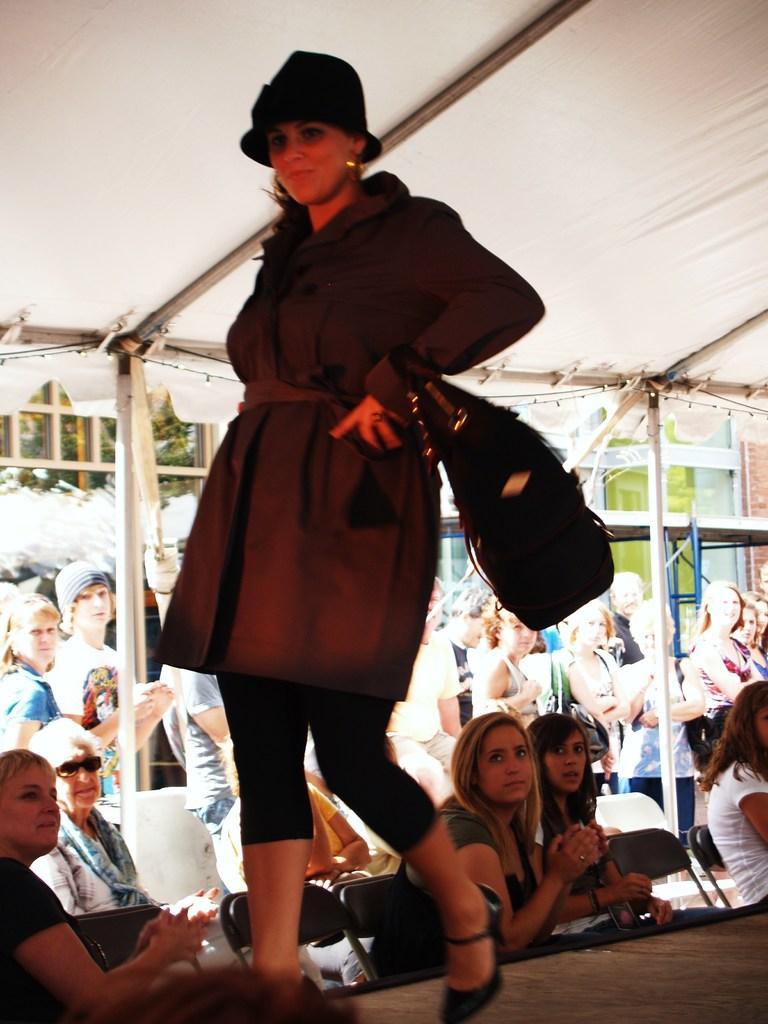Could you give a brief overview of what you see in this image? In the center of the image we can see a lady is walking on the stage and wearing a dress, cap and carrying a bag. In the background of the image we can see the tent, rods and some people are sitting on the chairs and some of them are standing. At the top of the image we can see the roof. At the bottom of the image we can see the floor. 